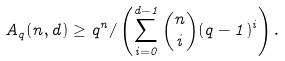Convert formula to latex. <formula><loc_0><loc_0><loc_500><loc_500>A _ { q } ( n , d ) \geq q ^ { n } / \left ( \sum _ { i = 0 } ^ { d - 1 } \binom { n } { i } ( q - 1 ) ^ { i } \right ) .</formula> 